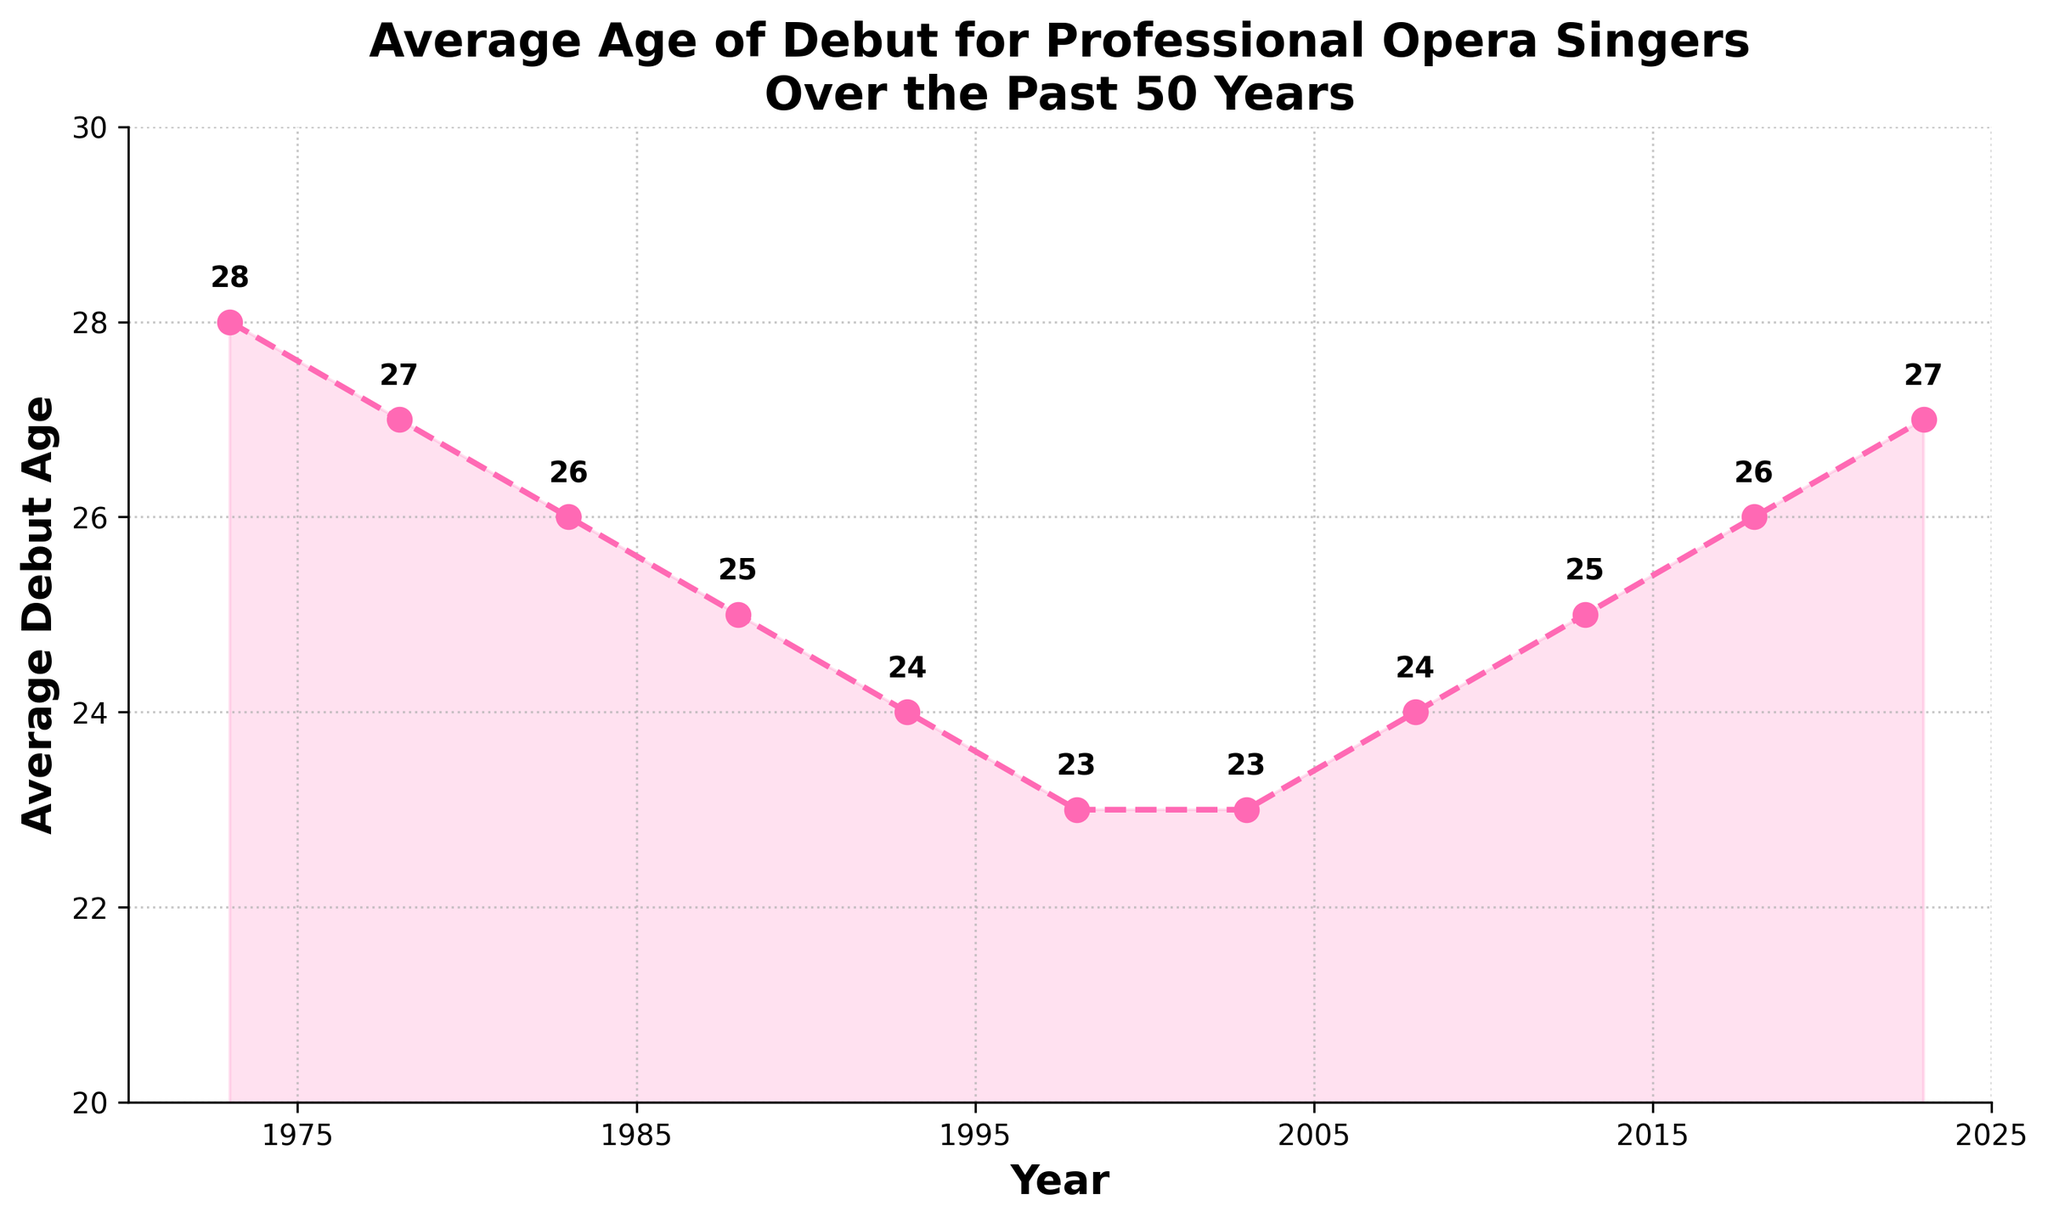What is the average debut age for professional opera singers in 1988? The plot shows the average debut age for each year. In 1988, the age marked is 25.
Answer: 25 Between which years did the average debut age drop the most? Look for the steepest decline in the plotted line. The age drops the most from 1973 (28) to 1998 (23).
Answer: 1973 to 1998 How does the average debut age in 2023 compare to 1973? Compare the values at the start and end points. In 1973, the age was 28, while in 2023 it is 27.
Answer: It decreased by 1 year What is the overall trend in the average debut age from 1973 to 2023? Observe the general direction of the line. It starts high in 1973, decreases until 1998, and then gradually increases again by 2023.
Answer: Decreasing, then increasing What is the lowest recorded average debut age in the past 50 years? Identify the lowest point on the plot. The smallest value is 23, appearing in 1998 and 2003.
Answer: 23 (1998 and 2003) What is the total number of years when the average debut age was below 25? Count the number of years where values are less than 25 on the y-axis. The years are 1993, 1998, and 2003.
Answer: 3 Compare the average debut age in 2008 and 2013. Which year had a higher age and by how much? Check the values for 2008 and 2013. In 2008, it's 24, and in 2013, it's 25. The difference is 1 year.
Answer: 2013 by 1 year During which periods did the average debut age stay the same? Look for flat lines on the plot. Between 1998 and 2003, the age stayed at 23.
Answer: 1998 to 2003 What is the difference in the average debut age between the highest and the lowest points in the figure? Identify the maximum (28 in 1973) and minimum (23 in 1998 and 2003) points. The difference is 28 - 23 = 5 years.
Answer: 5 years How many times did the average debut age increase after 1998? Observe the uptrend periods post-1998. Increases occur from 2003 to 2008 (23 to 24), 2008 to 2013 (24 to 25), and 2018 to 2023 (26 to 27).
Answer: 3 times 